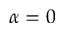<formula> <loc_0><loc_0><loc_500><loc_500>\alpha = 0</formula> 